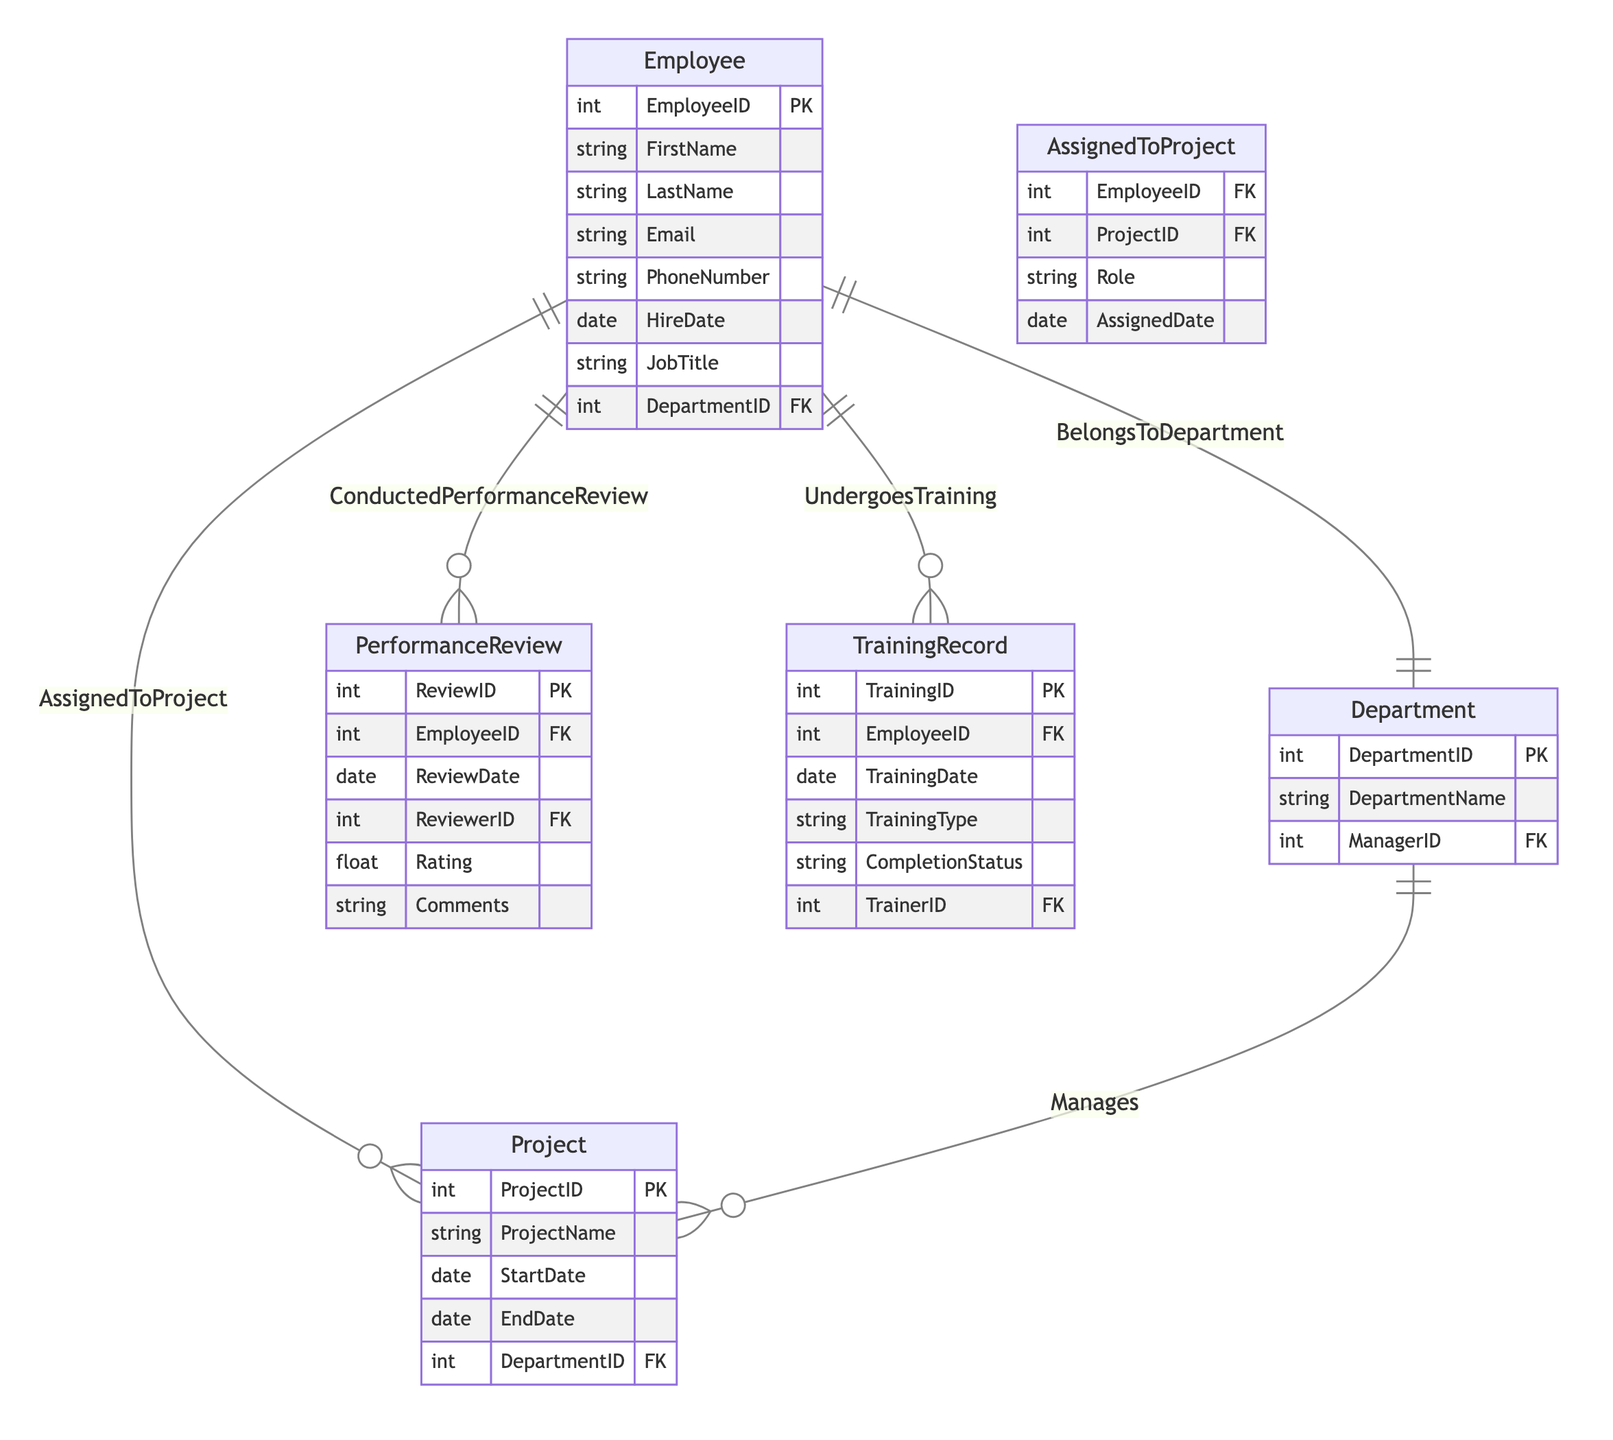What's the primary key of the Employee entity? The primary key of the Employee entity is EmployeeID, which uniquely identifies each employee in the database.
Answer: EmployeeID How many relationships are defined for the Project entity? The Project entity is involved in two relationships: "AssignedToProject" and "Manages".
Answer: Two What is the attribute type of ReviewDate in PerformanceReview? The attribute type of ReviewDate is date, indicating it stores the date of the performance review.
Answer: date Which entity is associated with TrainingRecord? The TrainingRecord is associated with the Employee entity as it tracks the training sessions that an employee undergoes.
Answer: Employee How many attributes does the Department entity have? The Department entity has three attributes: DepartmentID, DepartmentName, and ManagerID.
Answer: Three What is the relationship between Employee and PerformanceReview? The relationship is called "ConductedPerformanceReview", indicating that an employee has performance reviews conducted on them.
Answer: ConductedPerformanceReview If an employee is assigned to a project, what additional information is captured? The assignment captures the EmployeeID, ProjectID, Role, and AssignedDate, providing both identification and contextual info about the assignment.
Answer: EmployeeID, ProjectID, Role, AssignedDate Who is the foreign key in the Project entity? The foreign key in the Project entity is DepartmentID, which links each project to its respective department.
Answer: DepartmentID What is the review metric in the PerformanceReview entity? The review metric in the PerformanceReview entity is Rating, which likely evaluates the employee's performance on a numerical scale.
Answer: Rating 